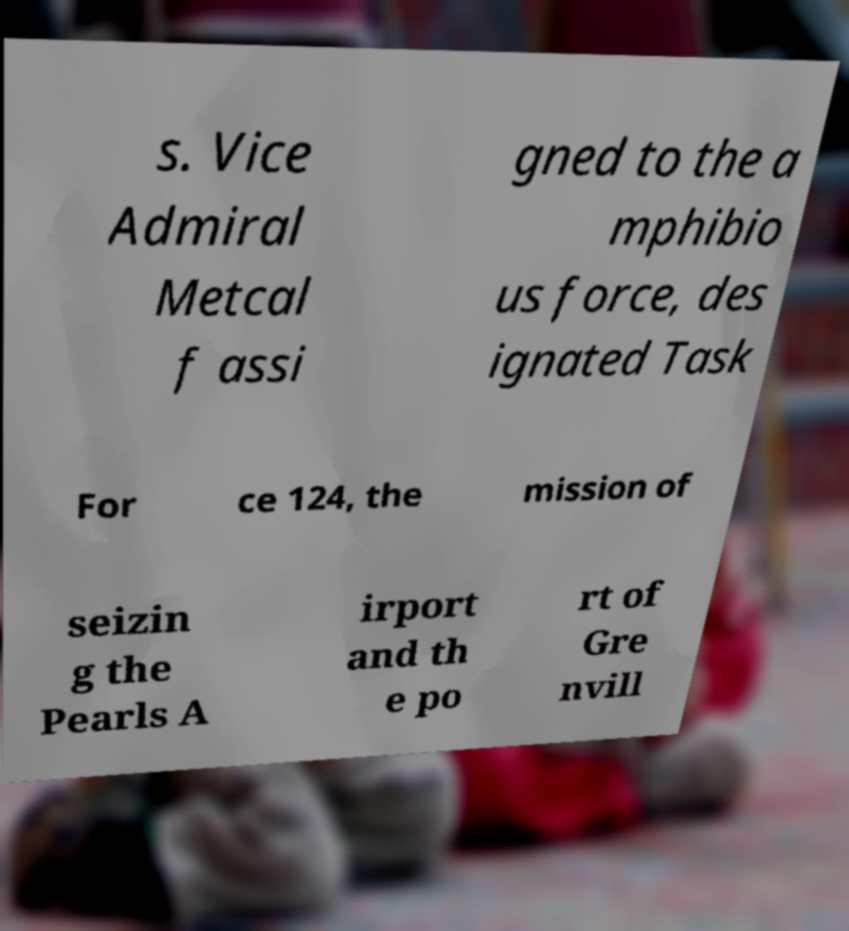What messages or text are displayed in this image? I need them in a readable, typed format. s. Vice Admiral Metcal f assi gned to the a mphibio us force, des ignated Task For ce 124, the mission of seizin g the Pearls A irport and th e po rt of Gre nvill 